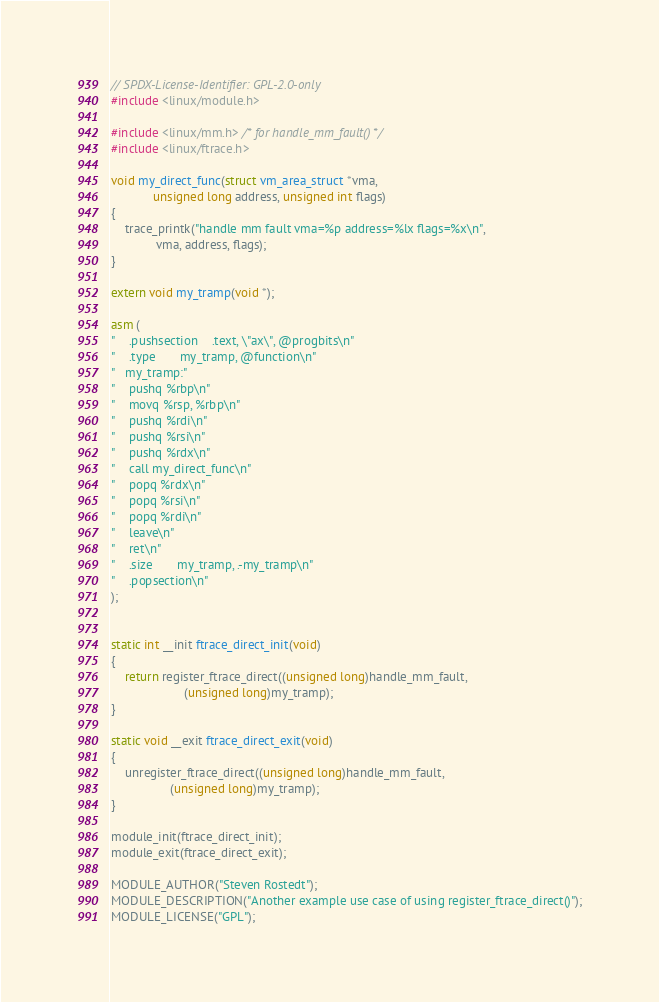Convert code to text. <code><loc_0><loc_0><loc_500><loc_500><_C_>// SPDX-License-Identifier: GPL-2.0-only
#include <linux/module.h>

#include <linux/mm.h> /* for handle_mm_fault() */
#include <linux/ftrace.h>

void my_direct_func(struct vm_area_struct *vma,
			unsigned long address, unsigned int flags)
{
	trace_printk("handle mm fault vma=%p address=%lx flags=%x\n",
		     vma, address, flags);
}

extern void my_tramp(void *);

asm (
"	.pushsection    .text, \"ax\", @progbits\n"
"	.type		my_tramp, @function\n"
"   my_tramp:"
"	pushq %rbp\n"
"	movq %rsp, %rbp\n"
"	pushq %rdi\n"
"	pushq %rsi\n"
"	pushq %rdx\n"
"	call my_direct_func\n"
"	popq %rdx\n"
"	popq %rsi\n"
"	popq %rdi\n"
"	leave\n"
"	ret\n"
"	.size		my_tramp, .-my_tramp\n"
"	.popsection\n"
);


static int __init ftrace_direct_init(void)
{
	return register_ftrace_direct((unsigned long)handle_mm_fault,
				     (unsigned long)my_tramp);
}

static void __exit ftrace_direct_exit(void)
{
	unregister_ftrace_direct((unsigned long)handle_mm_fault,
				 (unsigned long)my_tramp);
}

module_init(ftrace_direct_init);
module_exit(ftrace_direct_exit);

MODULE_AUTHOR("Steven Rostedt");
MODULE_DESCRIPTION("Another example use case of using register_ftrace_direct()");
MODULE_LICENSE("GPL");
</code> 